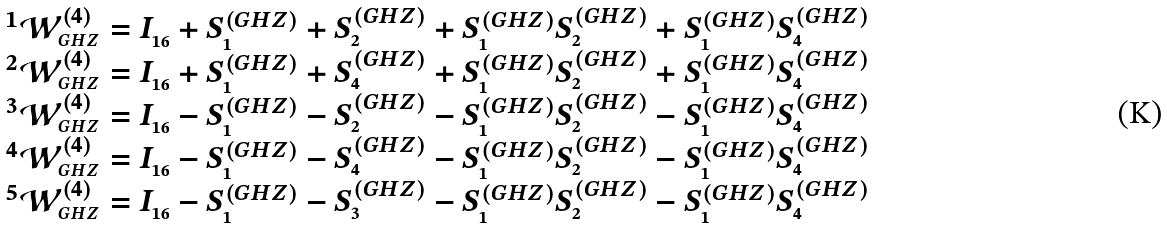Convert formula to latex. <formula><loc_0><loc_0><loc_500><loc_500>\begin{array} { c } ^ { 1 } \mathcal { W } _ { _ { G H Z } } ^ { ( 4 ) } = I _ { _ { 1 6 } } + S _ { _ { 1 } } ^ { ( G H Z ) } + S _ { _ { 2 } } ^ { ( G H Z ) } + S _ { _ { 1 } } ^ { ( G H Z ) } S _ { _ { 2 } } ^ { ( G H Z ) } + S _ { _ { 1 } } ^ { ( G H Z ) } S _ { _ { 4 } } ^ { ( G H Z ) } \\ ^ { 2 } \mathcal { W } _ { _ { G H Z } } ^ { ( 4 ) } = I _ { _ { 1 6 } } + S _ { _ { 1 } } ^ { ( G H Z ) } + S _ { _ { 4 } } ^ { ( G H Z ) } + S _ { _ { 1 } } ^ { ( G H Z ) } S _ { _ { 2 } } ^ { ( G H Z ) } + S _ { _ { 1 } } ^ { ( G H Z ) } S _ { _ { 4 } } ^ { ( G H Z ) } \\ ^ { 3 } \mathcal { W } _ { _ { G H Z } } ^ { ( 4 ) } = I _ { _ { 1 6 } } - S _ { _ { 1 } } ^ { ( G H Z ) } - S _ { _ { 2 } } ^ { ( G H Z ) } - S _ { _ { 1 } } ^ { ( G H Z ) } S _ { _ { 2 } } ^ { ( G H Z ) } - S _ { _ { 1 } } ^ { ( G H Z ) } S _ { _ { 4 } } ^ { ( G H Z ) } \\ ^ { 4 } \mathcal { W } _ { _ { G H Z } } ^ { ( 4 ) } = I _ { _ { 1 6 } } - S _ { _ { 1 } } ^ { ( G H Z ) } - S _ { _ { 4 } } ^ { ( G H Z ) } - S _ { _ { 1 } } ^ { ( G H Z ) } S _ { _ { 2 } } ^ { ( G H Z ) } - S _ { _ { 1 } } ^ { ( G H Z ) } S _ { _ { 4 } } ^ { ( G H Z ) } \\ ^ { 5 } \mathcal { W } _ { _ { G H Z } } ^ { ( 4 ) } = I _ { _ { 1 6 } } - S _ { _ { 1 } } ^ { ( G H Z ) } - S _ { _ { 3 } } ^ { ( G H Z ) } - S _ { _ { 1 } } ^ { ( G H Z ) } S _ { _ { 2 } } ^ { ( G H Z ) } - S _ { _ { 1 } } ^ { ( G H Z ) } S _ { _ { 4 } } ^ { ( G H Z ) } \\ \end{array}</formula> 